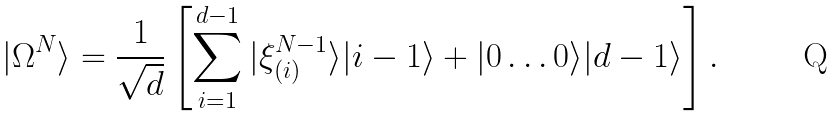<formula> <loc_0><loc_0><loc_500><loc_500>| \Omega ^ { N } \rangle = \frac { 1 } { \sqrt { d } } \left [ \sum ^ { d - 1 } _ { i = 1 } | \xi ^ { N - 1 } _ { ( i ) } \rangle | i - 1 \rangle + | 0 \dots 0 \rangle | d - 1 \rangle \right ] .</formula> 